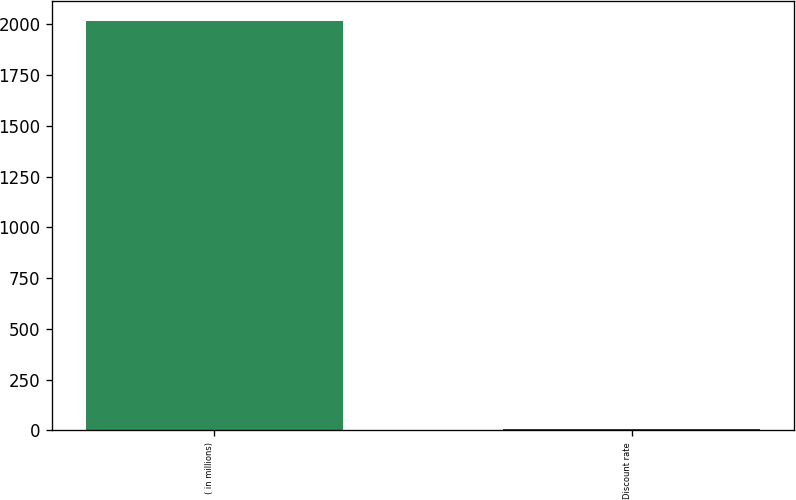<chart> <loc_0><loc_0><loc_500><loc_500><bar_chart><fcel>( in millions)<fcel>Discount rate<nl><fcel>2015<fcel>4.58<nl></chart> 